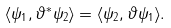<formula> <loc_0><loc_0><loc_500><loc_500>\langle \psi _ { 1 } , \vartheta ^ { * } \psi _ { 2 } \rangle = \langle \psi _ { 2 } , \vartheta \psi _ { 1 } \rangle .</formula> 